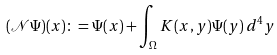<formula> <loc_0><loc_0><loc_500><loc_500>( \mathcal { N } \Psi ) ( x ) \colon = \Psi ( x ) + \int _ { \Omega } K ( x , y ) \Psi ( y ) \, d ^ { 4 } y</formula> 